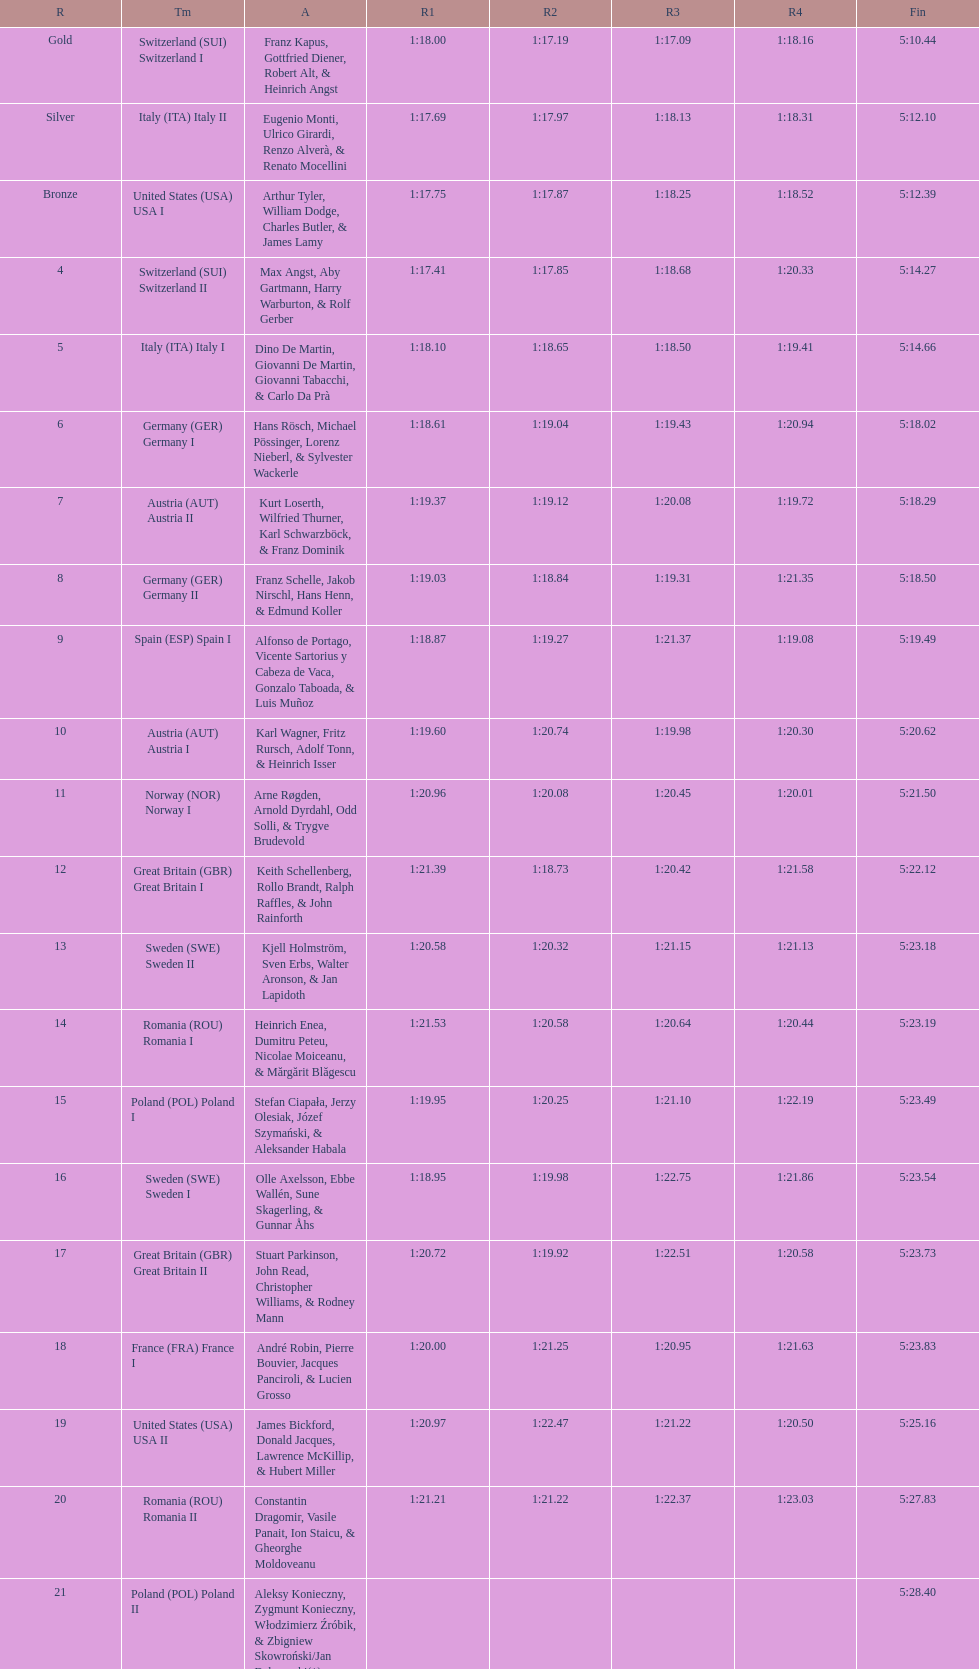Which team won the most runs? Switzerland. 